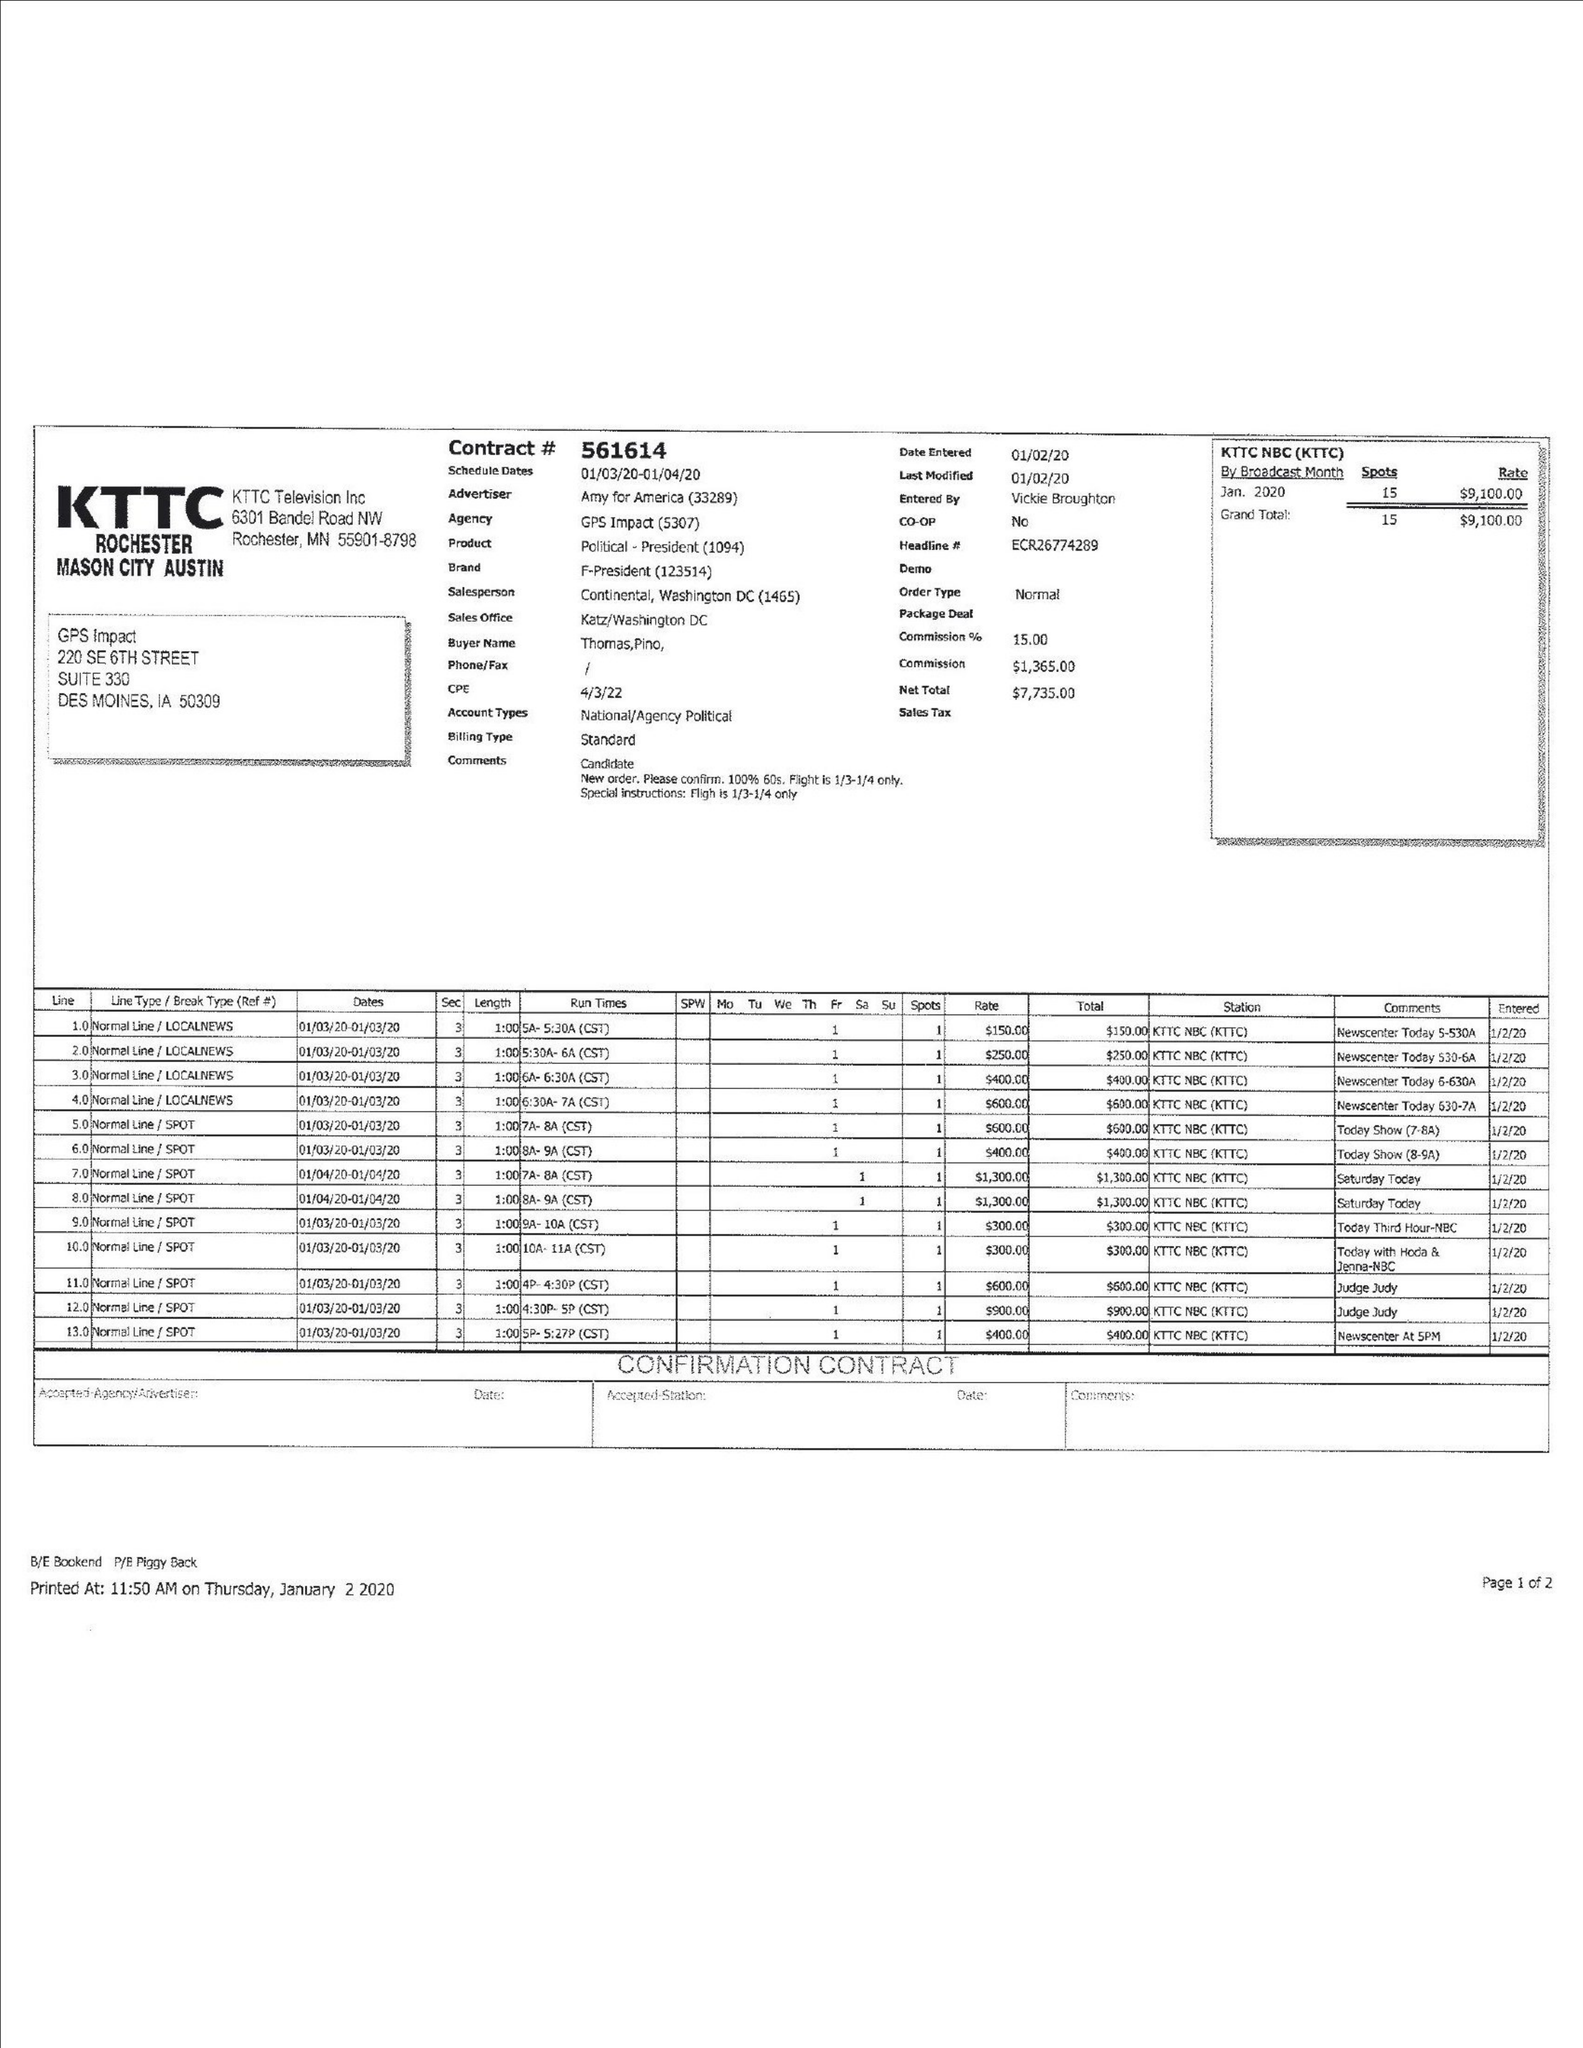What is the value for the flight_from?
Answer the question using a single word or phrase. 01/03/20 